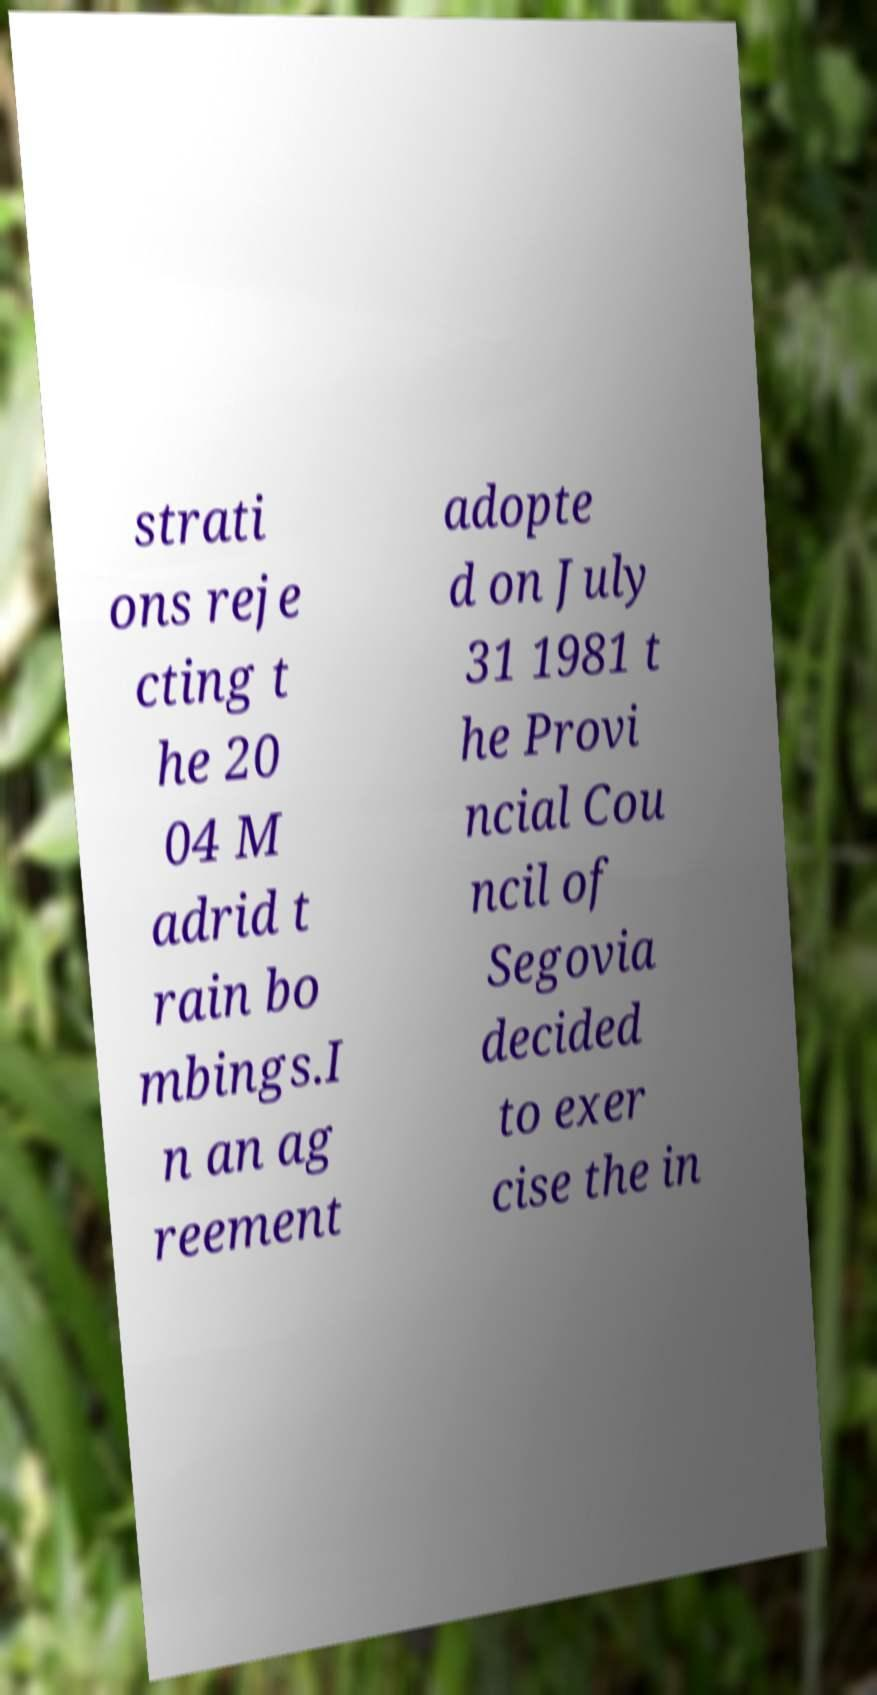For documentation purposes, I need the text within this image transcribed. Could you provide that? strati ons reje cting t he 20 04 M adrid t rain bo mbings.I n an ag reement adopte d on July 31 1981 t he Provi ncial Cou ncil of Segovia decided to exer cise the in 